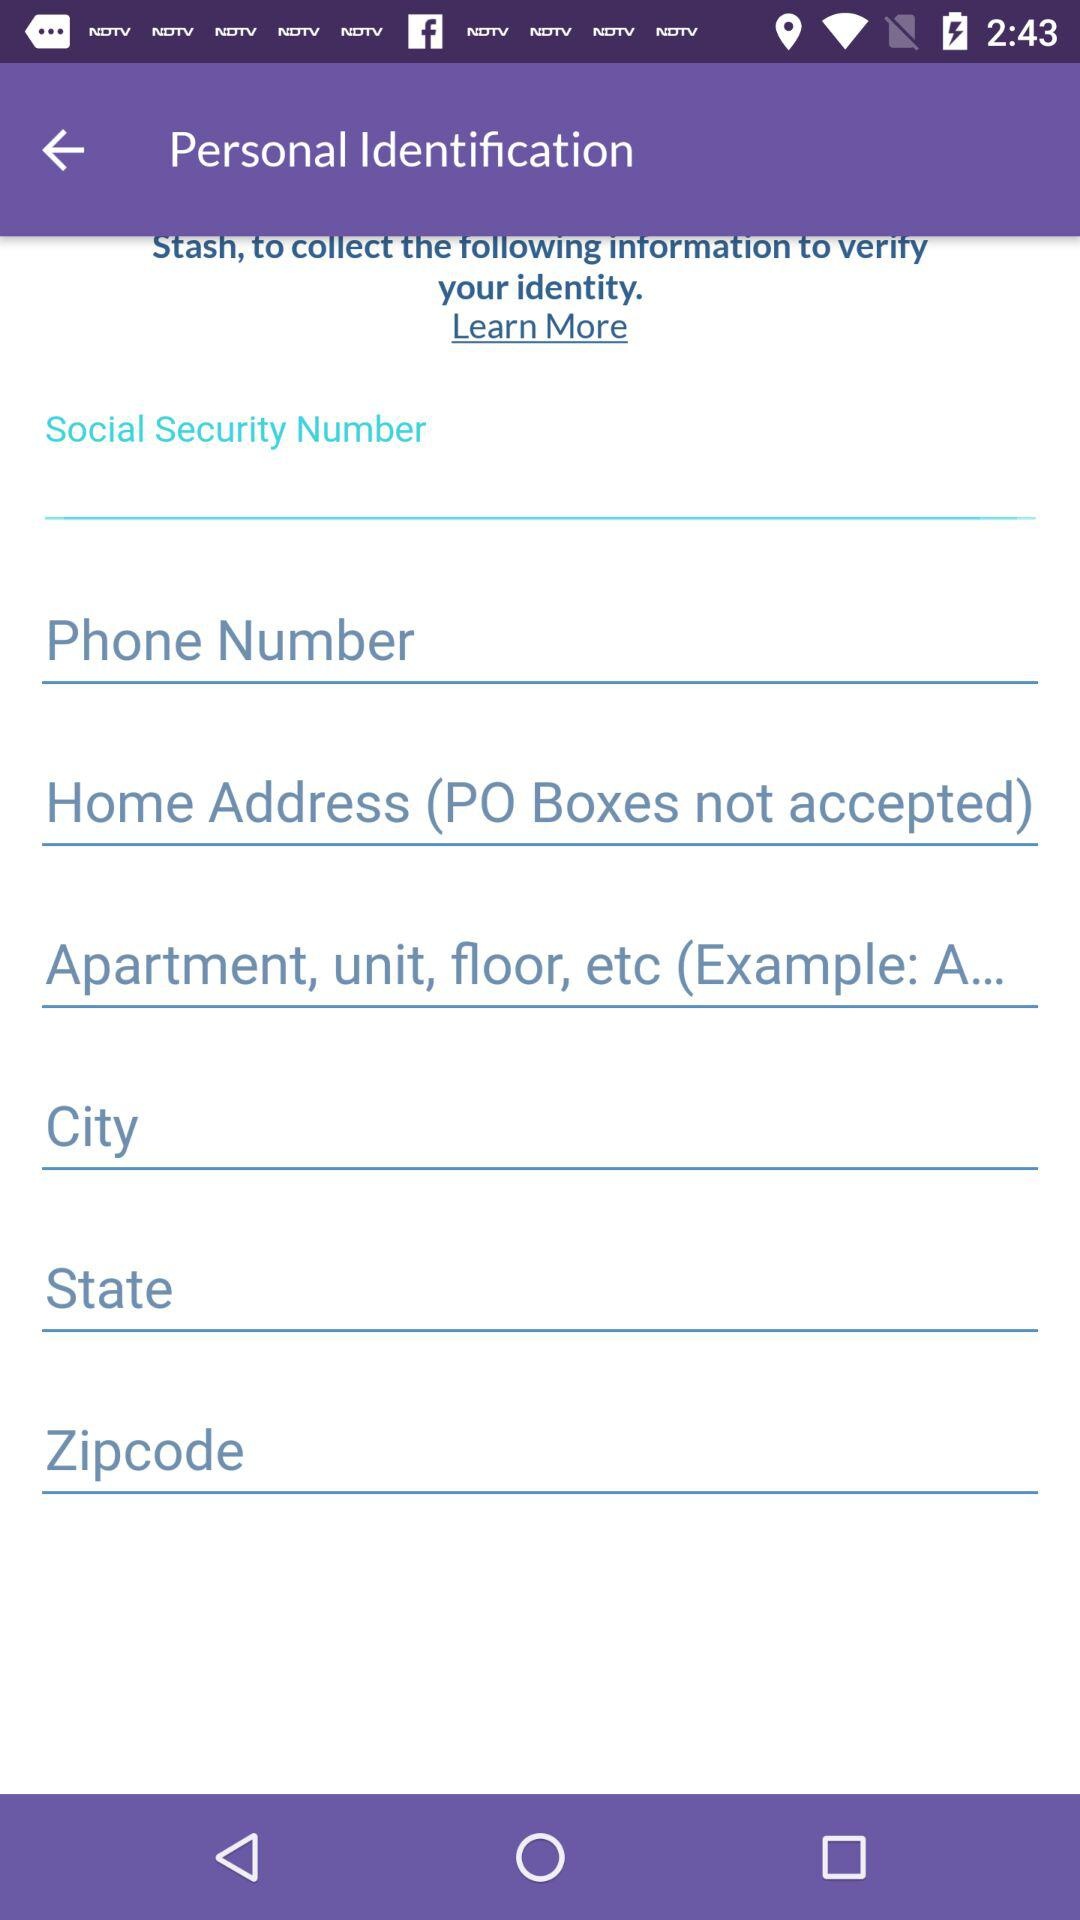How many text inputs are there for collecting personal identification information?
Answer the question using a single word or phrase. 6 